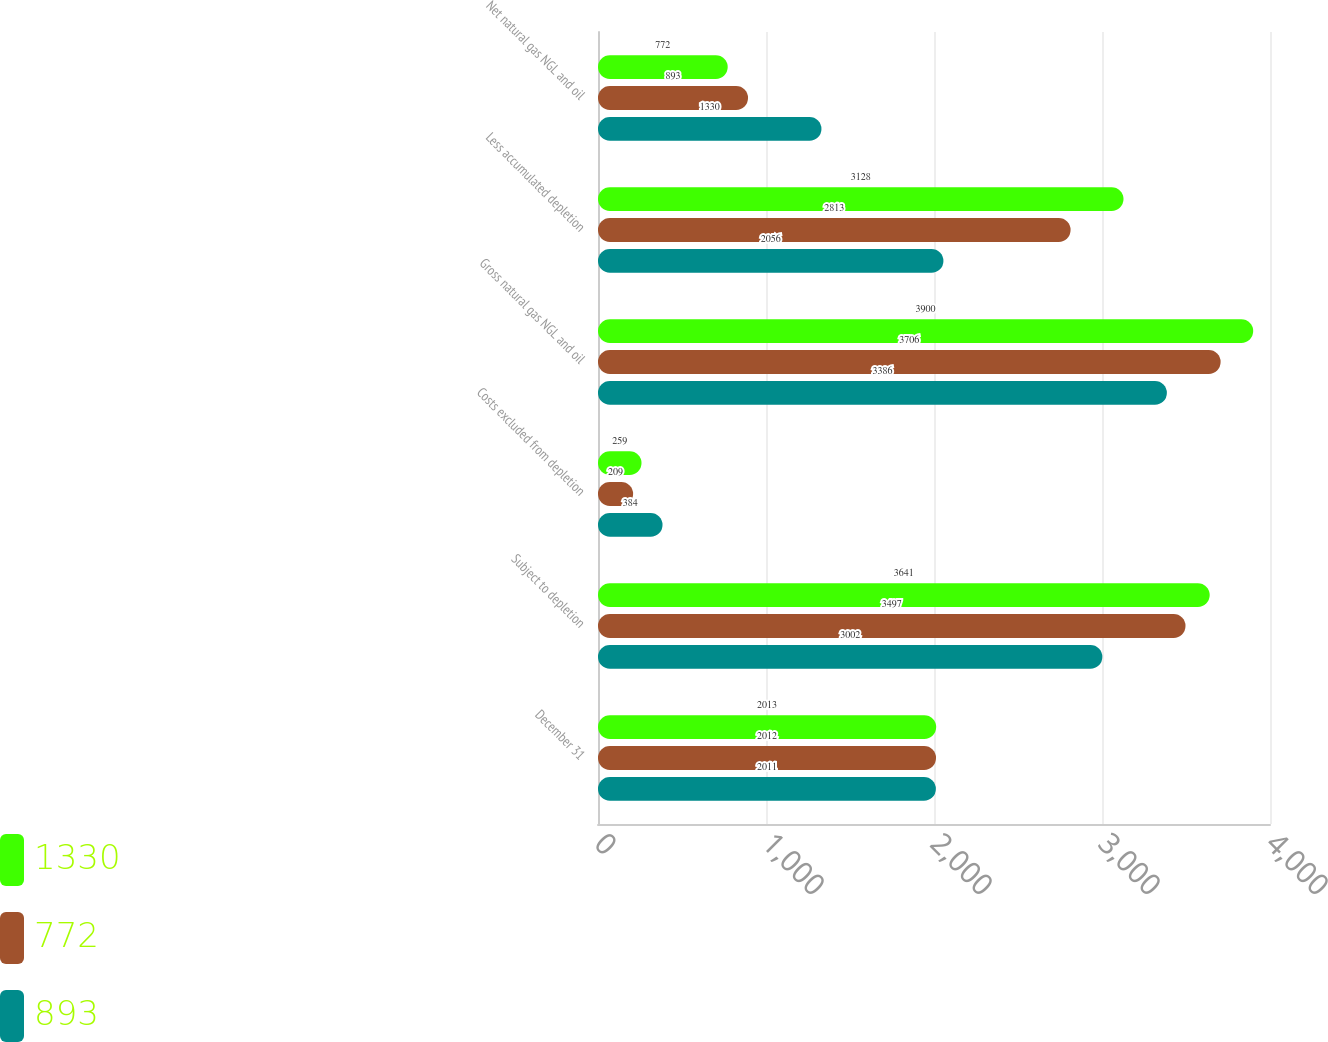Convert chart to OTSL. <chart><loc_0><loc_0><loc_500><loc_500><stacked_bar_chart><ecel><fcel>December 31<fcel>Subject to depletion<fcel>Costs excluded from depletion<fcel>Gross natural gas NGL and oil<fcel>Less accumulated depletion<fcel>Net natural gas NGL and oil<nl><fcel>1330<fcel>2013<fcel>3641<fcel>259<fcel>3900<fcel>3128<fcel>772<nl><fcel>772<fcel>2012<fcel>3497<fcel>209<fcel>3706<fcel>2813<fcel>893<nl><fcel>893<fcel>2011<fcel>3002<fcel>384<fcel>3386<fcel>2056<fcel>1330<nl></chart> 